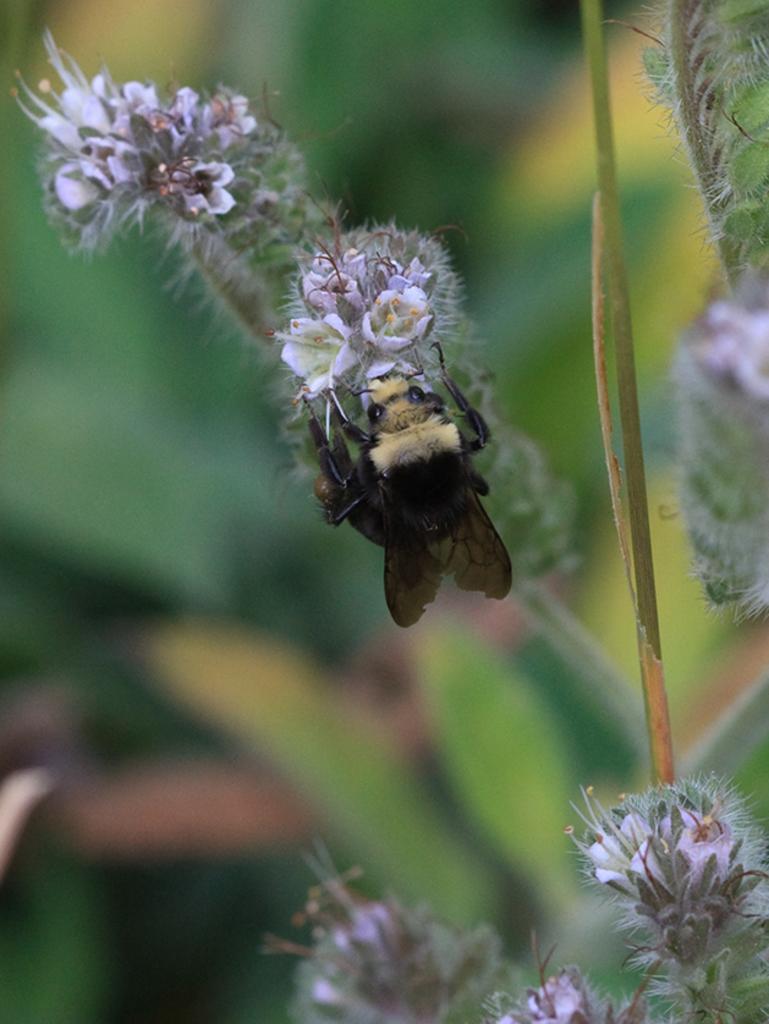How would you summarize this image in a sentence or two? In the image there is a fly on the white flowers. To the right bottom corner of the image there are white flowers. And in the background there are leaves. 